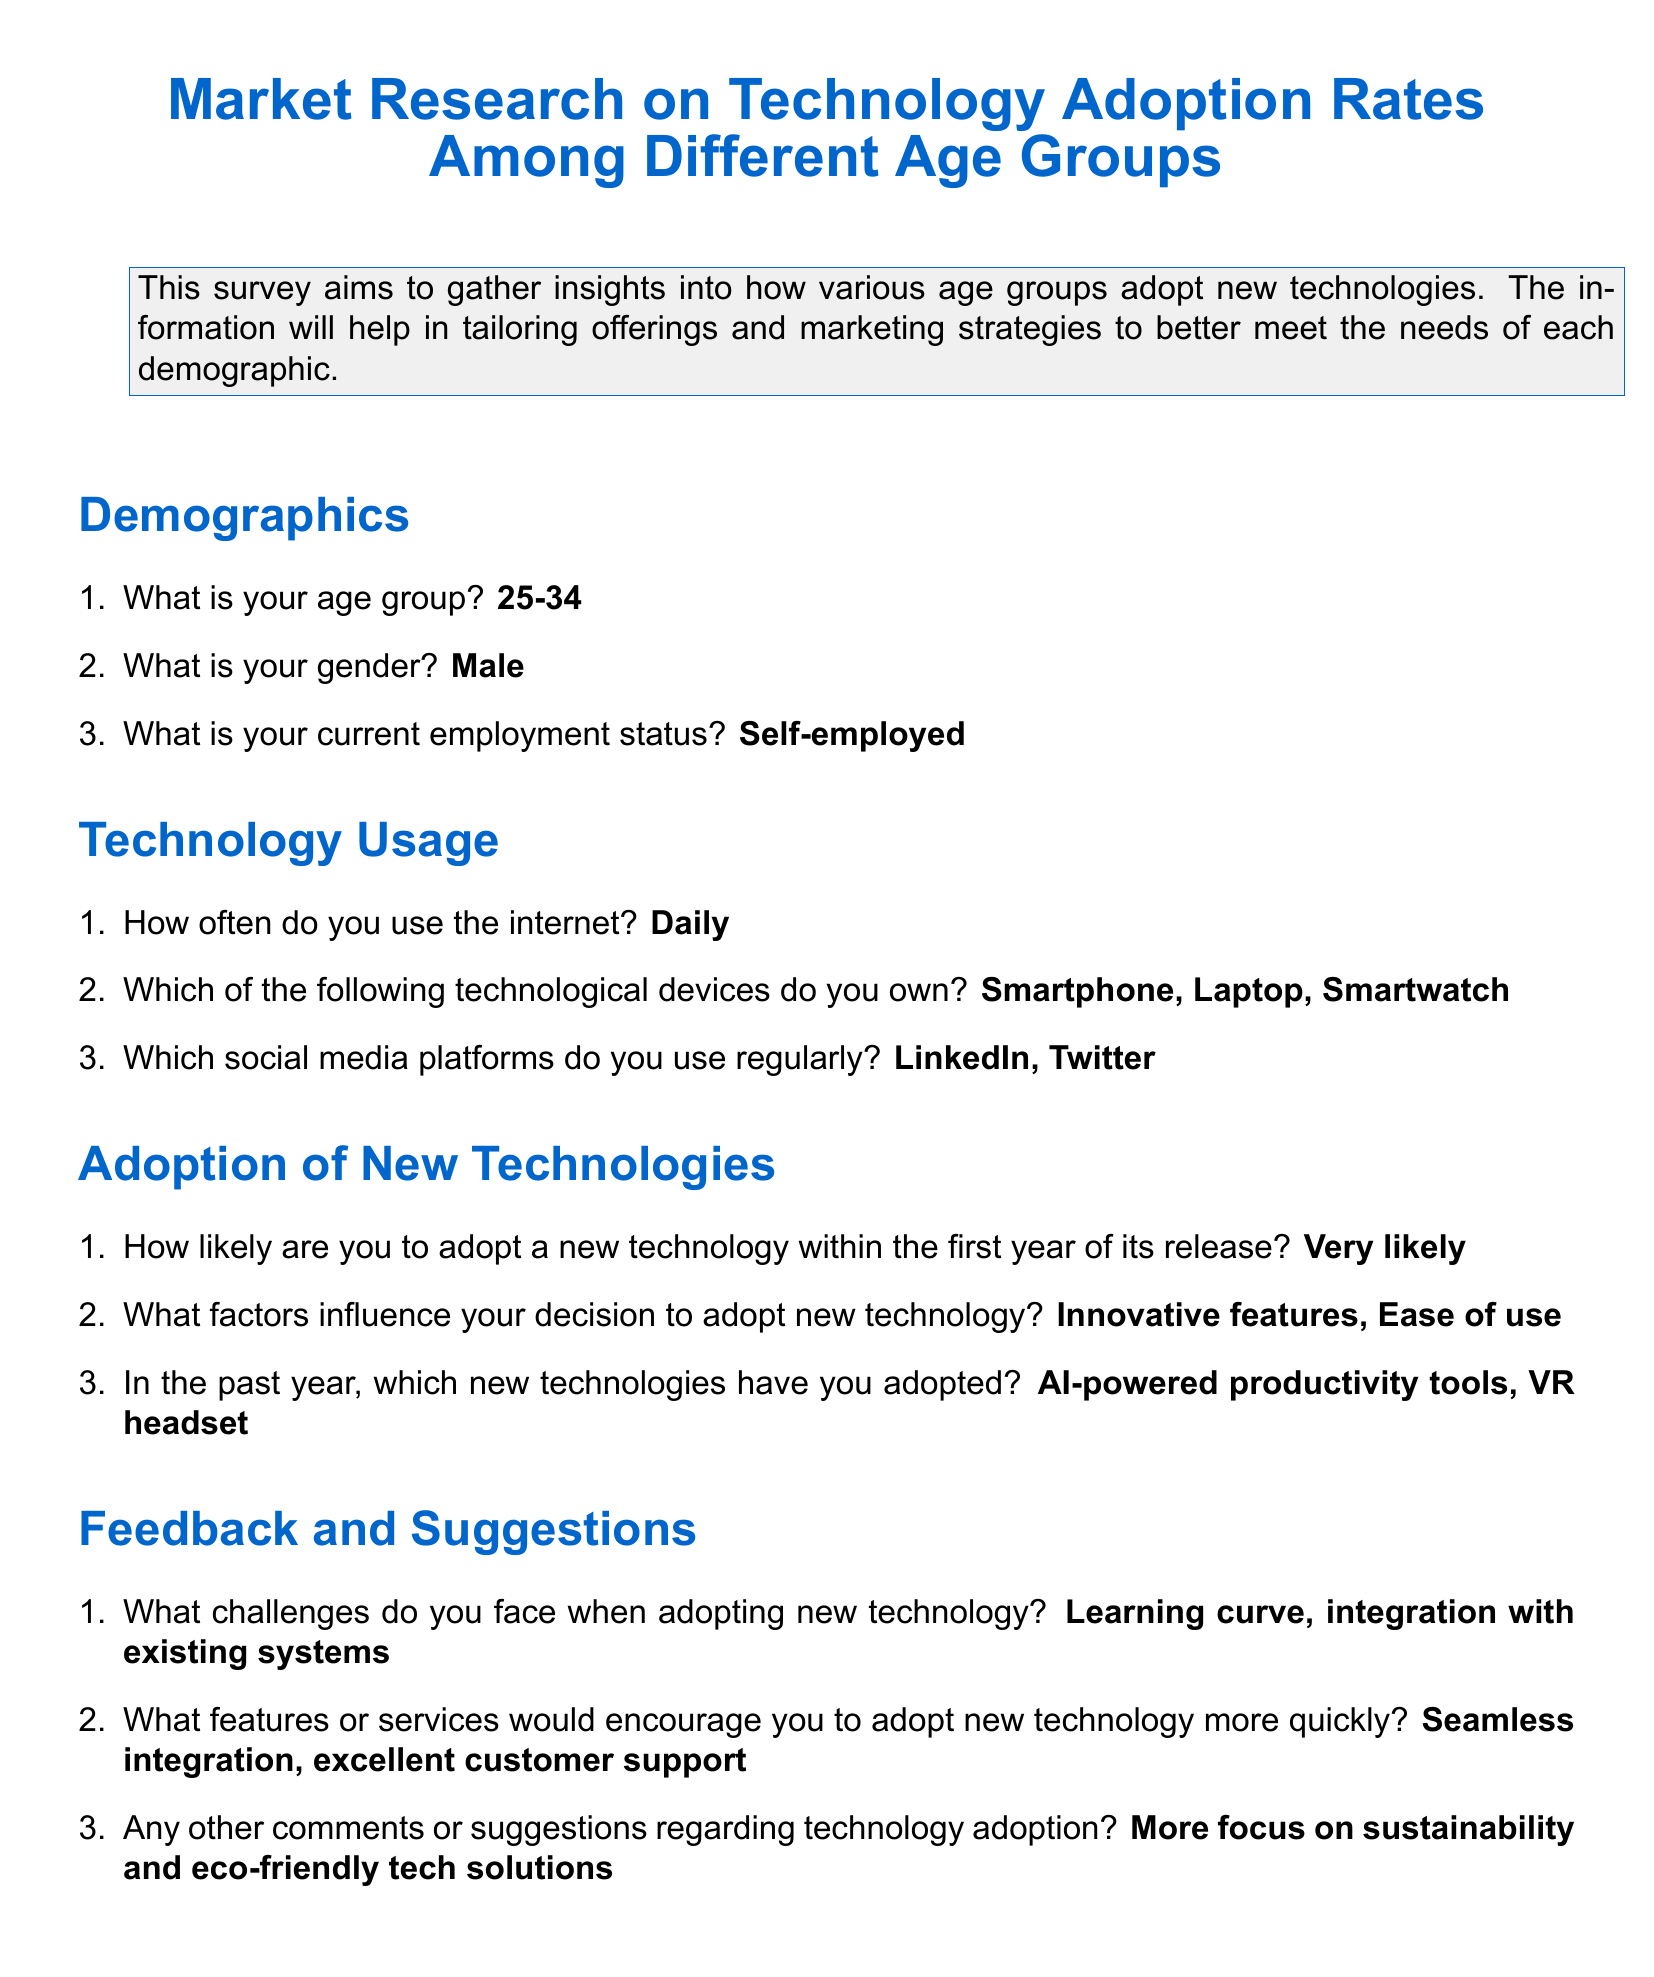What is the age group of the respondent? The age group is specifically mentioned in the demographics section of the document.
Answer: 25-34 What is the gender of the respondent? The gender is specified in the demographics section of the document.
Answer: Male What is the employment status of the respondent? Employment status is included in the demographics section of the document.
Answer: Self-employed How often does the respondent use the internet? This information can be found in the technology usage section of the document.
Answer: Daily Which devices does the respondent own? The document lists the devices owned by the respondent in the technology usage section.
Answer: Smartphone, Laptop, Smartwatch What challenges does the respondent face when adopting new technology? This question can be answered by referring to the feedback and suggestions section of the document.
Answer: Learning curve, integration with existing systems What factors influence the respondent's decision to adopt new technology? The factors are mentioned in the adoption of new technologies section of the document.
Answer: Innovative features, Ease of use Which new technologies has the respondent adopted in the past year? The information is provided in the adoption of new technologies section of the document.
Answer: AI-powered productivity tools, VR headset What features would encourage the respondent to adopt new technology more quickly? The feedback section of the document includes these features.
Answer: Seamless integration, excellent customer support 